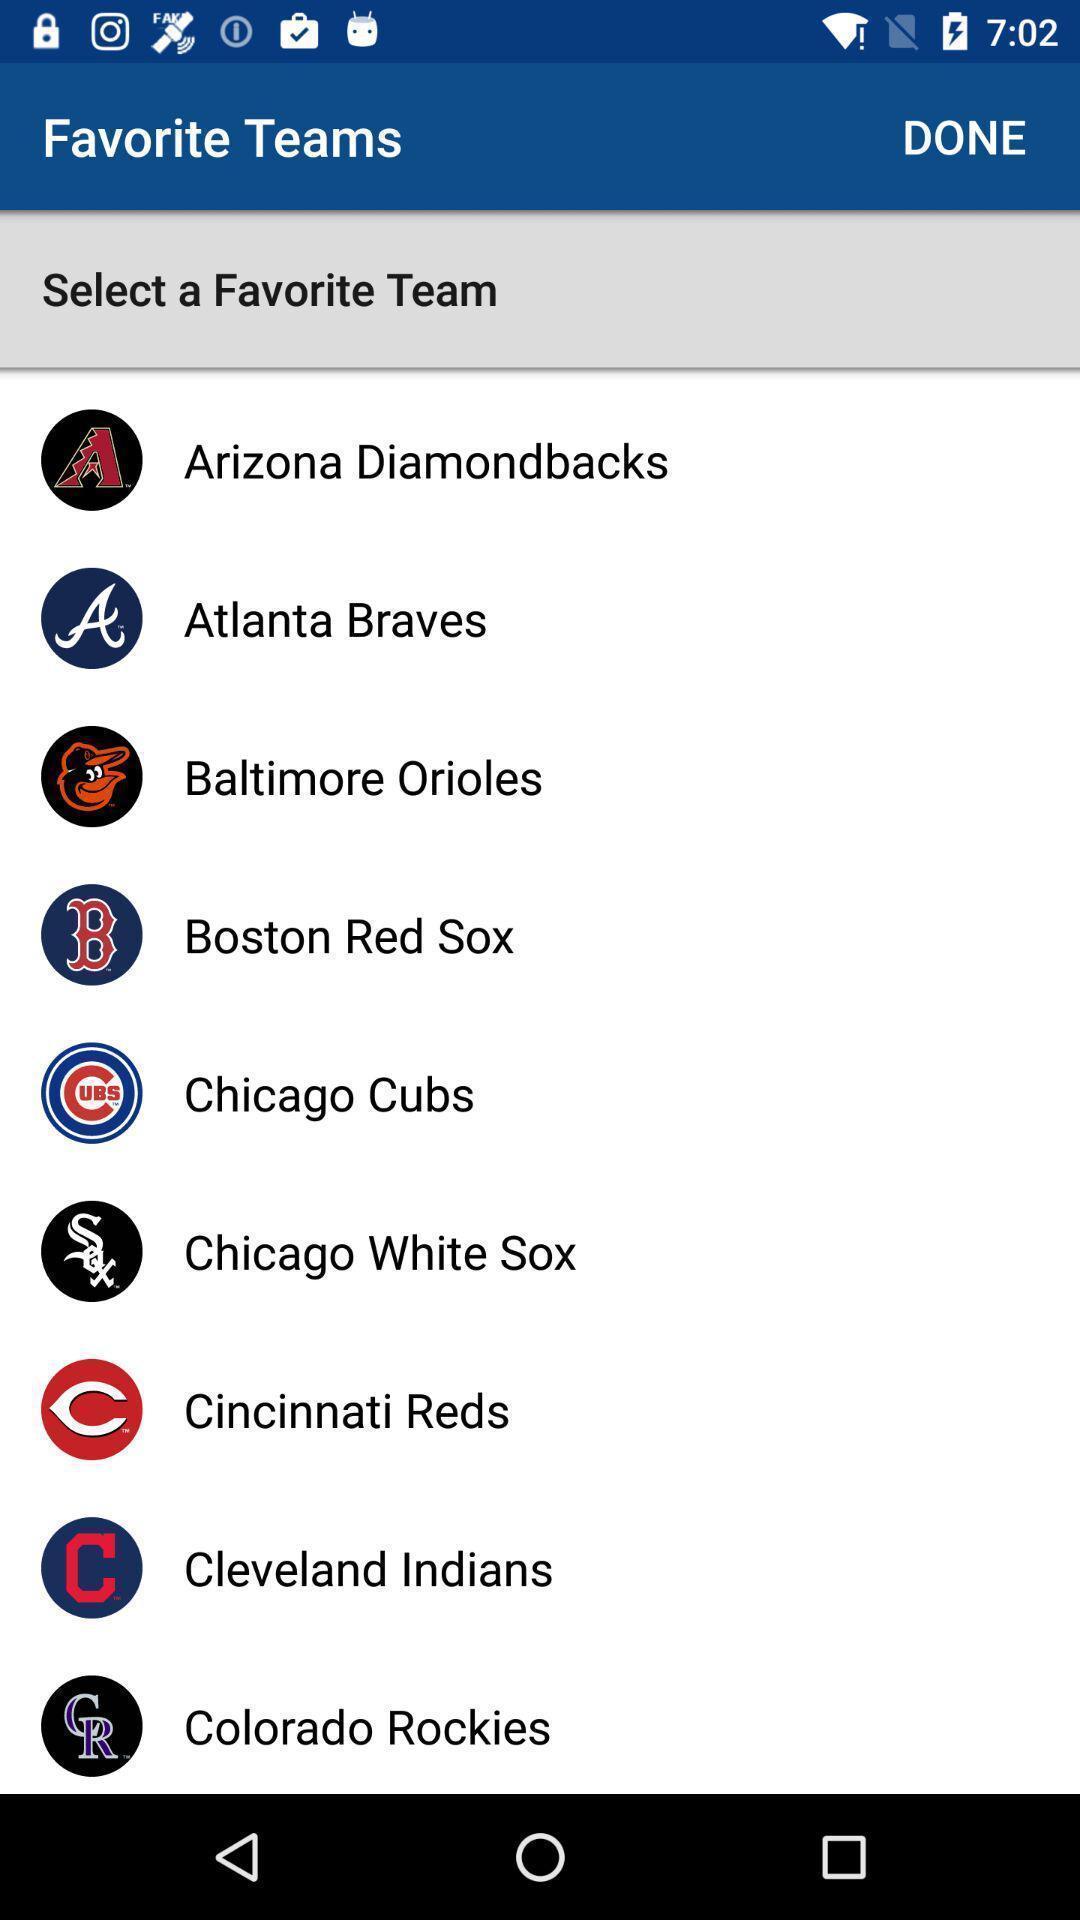Describe the content in this image. Scree showing list of various teams in gaming app. 